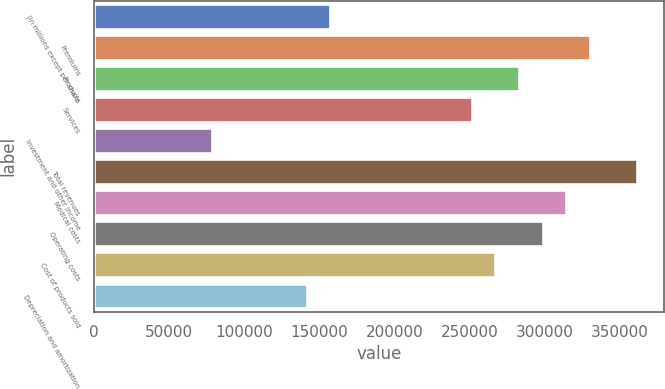<chart> <loc_0><loc_0><loc_500><loc_500><bar_chart><fcel>(in millions except per share<fcel>Premiums<fcel>Products<fcel>Services<fcel>Investment and other income<fcel>Total revenues<fcel>Medical costs<fcel>Operating costs<fcel>Cost of products sold<fcel>Depreciation and amortization<nl><fcel>157107<fcel>329923<fcel>282791<fcel>251370<fcel>78554.4<fcel>361344<fcel>314212<fcel>298502<fcel>267081<fcel>141396<nl></chart> 